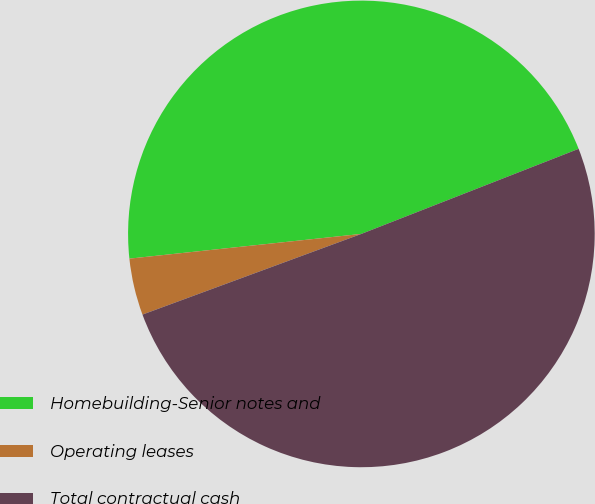<chart> <loc_0><loc_0><loc_500><loc_500><pie_chart><fcel>Homebuilding-Senior notes and<fcel>Operating leases<fcel>Total contractual cash<nl><fcel>45.75%<fcel>3.93%<fcel>50.32%<nl></chart> 